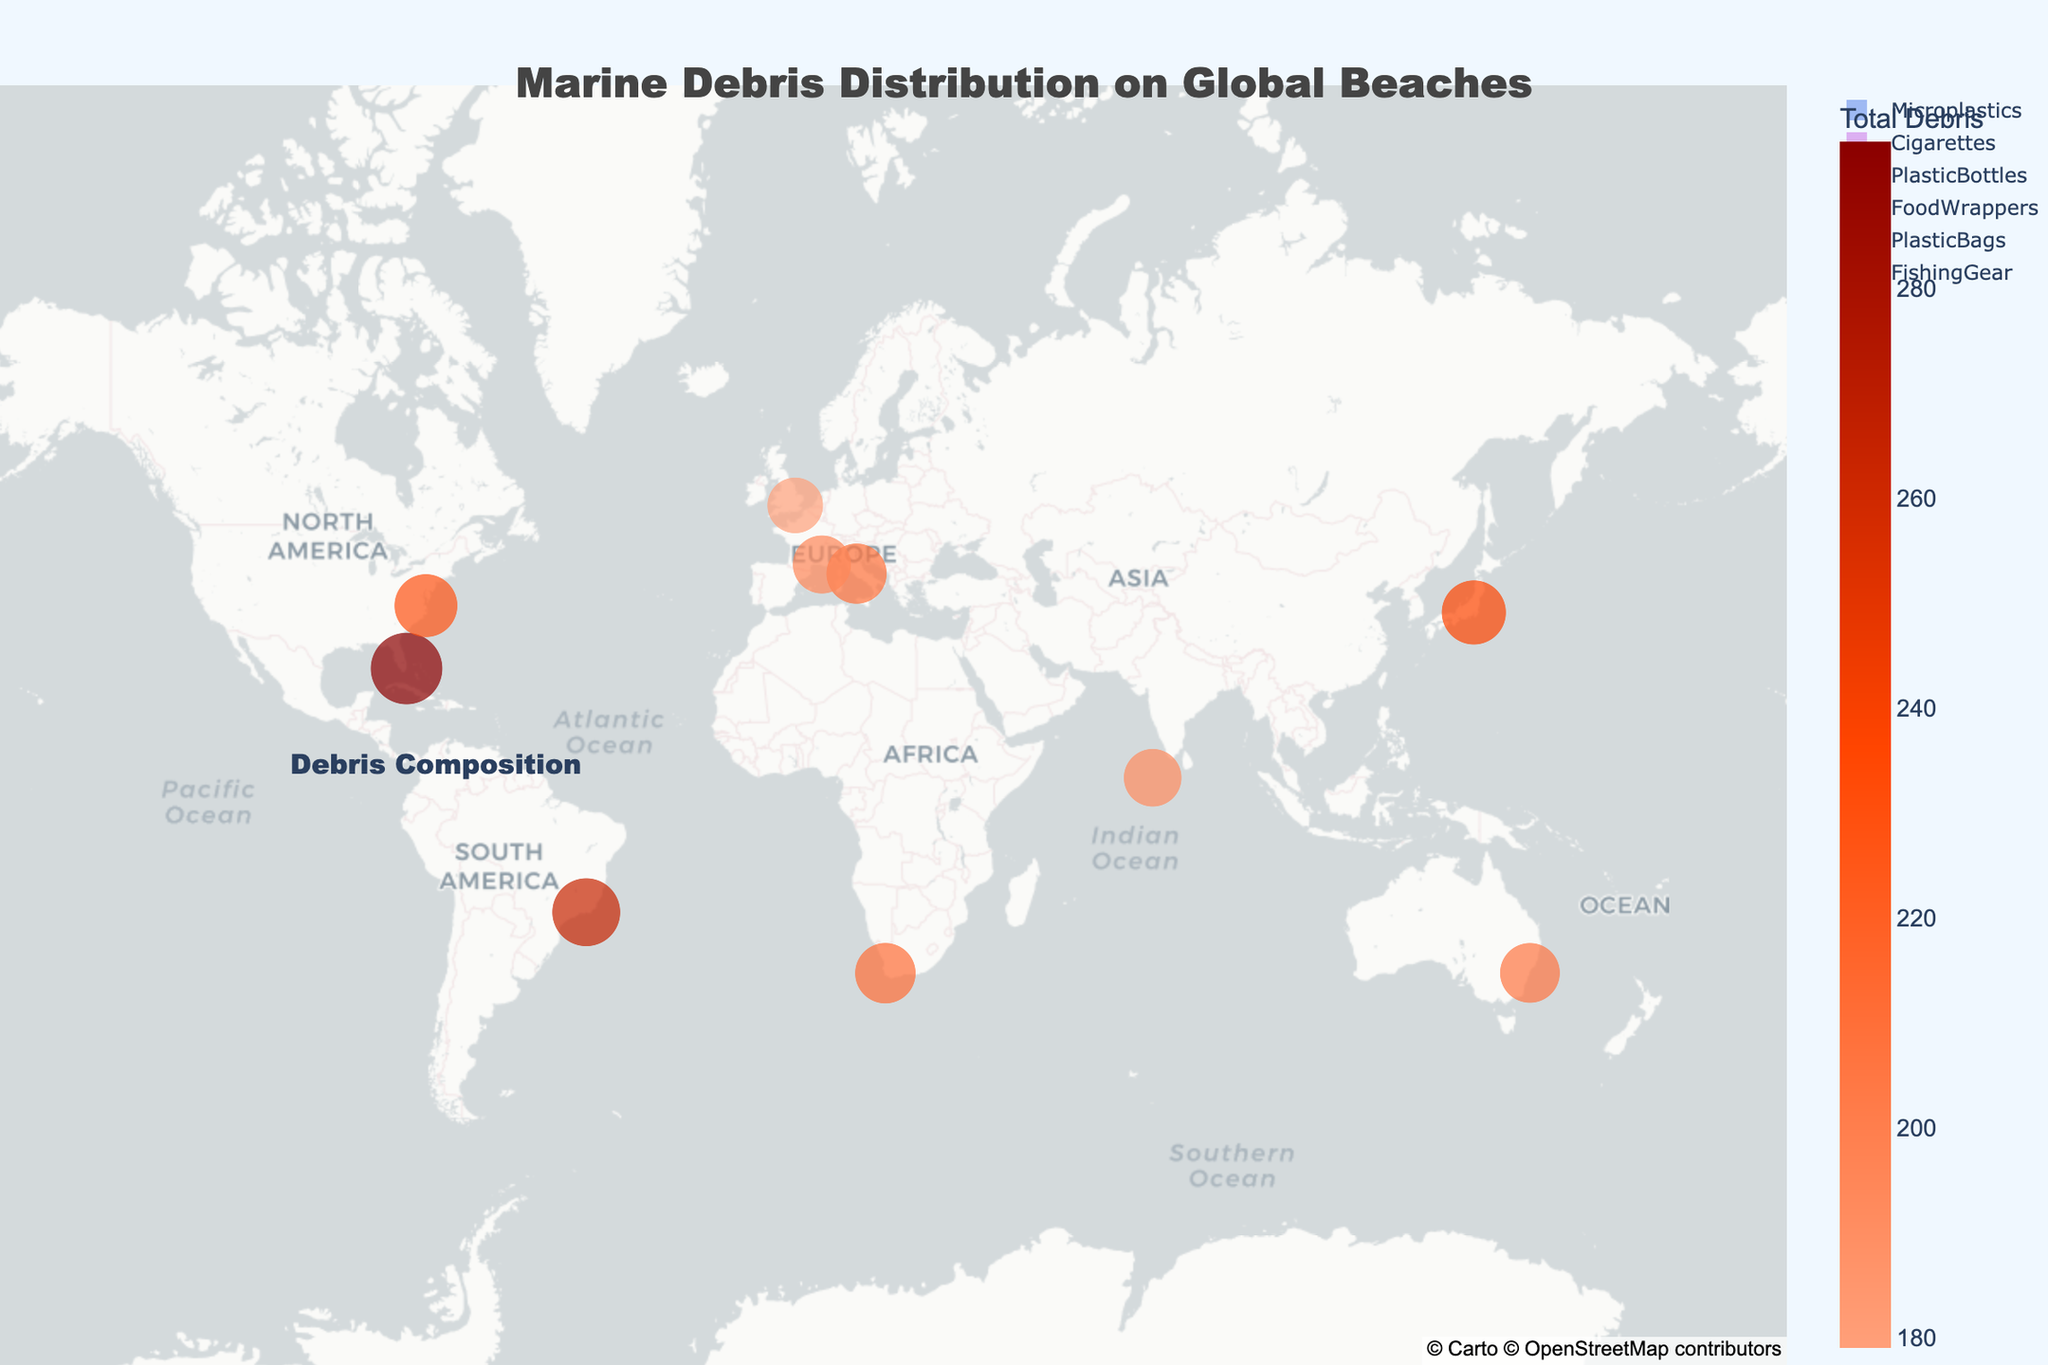Which beach has the highest amount of total debris? The scatter plot displays the size of the circles representing the total debris at each beach. The biggest circle will indicate the beach with the most debris. Miami Beach has the largest circle with a total debris count of 354.
Answer: Miami Beach How many beaches were analyzed in this plot? By counting the number of circles on the scatter map, we can determine the number of beaches included in the analysis.
Answer: 10 What is the title of the map? The title is displayed at the top of the map, which describes the content of the visual representation.
Answer: Marine Debris Distribution on Global Beaches Which country’s beach has the least amount of total debris? The size of the circles indicates the amount of debris. The smallest circle represents the beach with the least amount of debris. Hulhumale Beach in Maldives has the smallest circle with a total debris count of 221.
Answer: Maldives How does the total debris at Bondi Beach compare to that at Copacabana Beach? By comparing the size of the circles and the hover data on the map for Bondi Beach and Copacabana Beach, we can see that Copacabana Beach has a higher total debris count of 322 compared to Bondi Beach’s 251.
Answer: Copacabana Beach has more debris than Bondi Beach What is the most common type of debris found across all beaches? Looking at the pie chart for debris composition, the largest segment will indicate the most common type of debris.
Answer: Microplastics How does the amount of plastic bottles found at Odaiba Beach compare to Virginia Beach? By checking the hover data on the map for both beaches, Odaiba Beach has 52 plastic bottles whereas Virginia Beach has 42 plastic bottles.
Answer: Odaiba Beach has more plastic bottles than Virginia Beach What is the average total debris count among all analyzed beaches? Sum all the total debris values from each beach and then divide by the number of beaches: (251+247+289+354+212+322+221+270+231+251)/10. The total sum is 2,648; dividing by 10 gives us an average of 264.8.
Answer: 264.8 Which beach has more cigarettes debris: Miami Beach or Ostia Beach? By checking the hover data for cigarettes at Miami Beach (71) and Ostia Beach (62), Miami Beach has a higher number of cigarette debris.
Answer: Miami Beach Are there any beaches with a high amount of fishing gear as debris? Examining the size of the segments in the pie chart for fishing gear indicates that none of the segments are significantly large compared to others, suggesting no beach has an exceptionally high amount of fishing gear.
Answer: No 